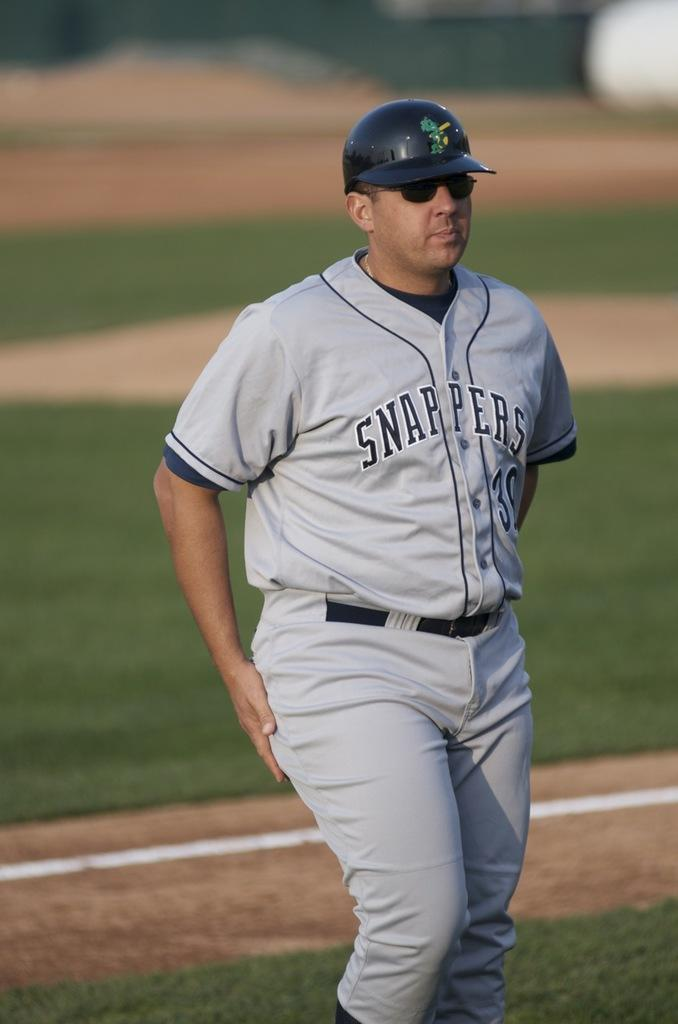<image>
Present a compact description of the photo's key features. A player for the Snappers wears sunglasses and a batting helmet. 